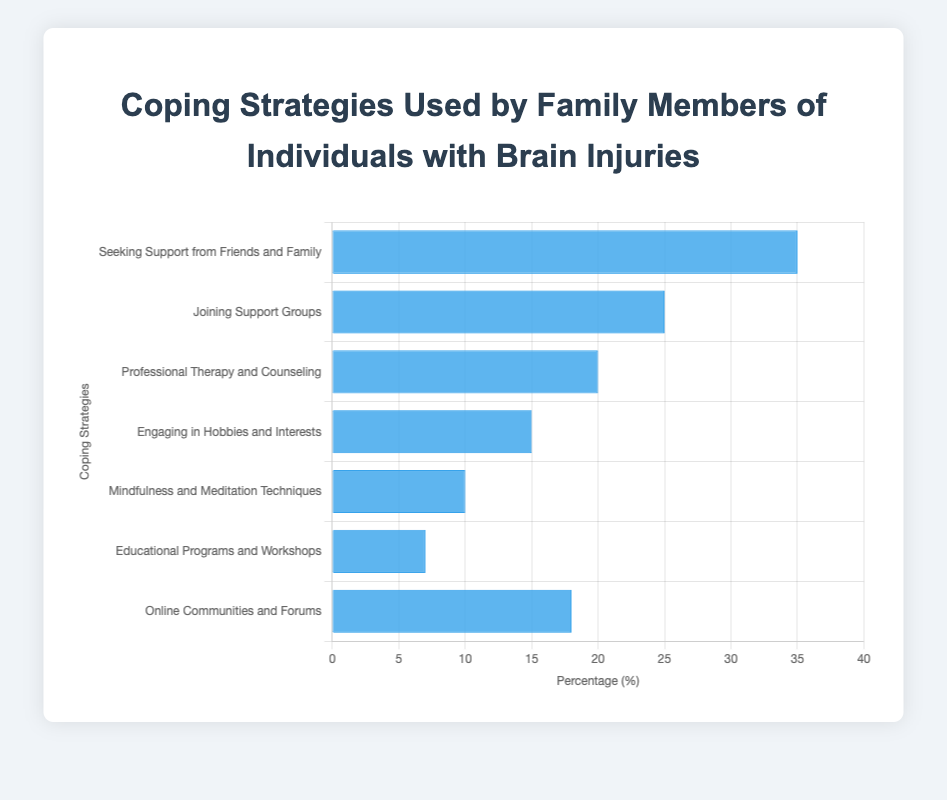What percentage of family members use Professional Therapy and Counseling? The figure shows different percentages for various coping strategies. Look for "Professional Therapy and Counseling" and note its value.
Answer: 20% Which coping strategy is used by the highest percentage of family members? Identify the tallest blue bar. The bar with the highest value represents the most used coping strategy.
Answer: Seeking Support from Friends and Family What is the sum of percentages for Joining Support Groups and Educational Programs and Workshops? Find the percentages for both "Joining Support Groups" and "Educational Programs and Workshops". Add these values together (25% + 7%).
Answer: 32% Compare the percentages of Mindfulness and Meditation Techniques and Online Communities and Forums. Which is higher, and by how much? Determine the percentages for both "Mindfulness and Meditation Techniques" (10%) and "Online Communities and Forums" (18%). Subtract the smaller percentage from the larger one (18% - 10%).
Answer: Online Communities and Forums is higher by 8% What is the average percentage of all the coping strategies shown? Add up all the percentages (35 + 25 + 20 + 15 + 10 + 7 + 18) to get a total of 130. Divide by the number of strategies (7).
Answer: 18.57% By how much does Engaging in Hobbies and Interests exceed Educational Programs and Workshops? Find the percentages for "Engaging in Hobbies and Interests" (15%) and "Educational Programs and Workshops" (7%). Subtract the smaller percentage from the larger one (15% - 7%).
Answer: 8% Rank the coping strategies from most to least used. List the strategies by their percentages in descending order: Seeking Support from Friends and Family (35%), Joining Support Groups (25%), Professional Therapy and Counseling (20%), Online Communities and Forums (18%), Engaging in Hobbies and Interests (15%), Mindfulness and Meditation Techniques (10%), Educational Programs and Workshops (7%).
Answer: Seeking Support from Friends and Family, Joining Support Groups, Professional Therapy and Counseling, Online Communities and Forums, Engaging in Hobbies and Interests, Mindfulness and Meditation Techniques, Educational Programs and Workshops 